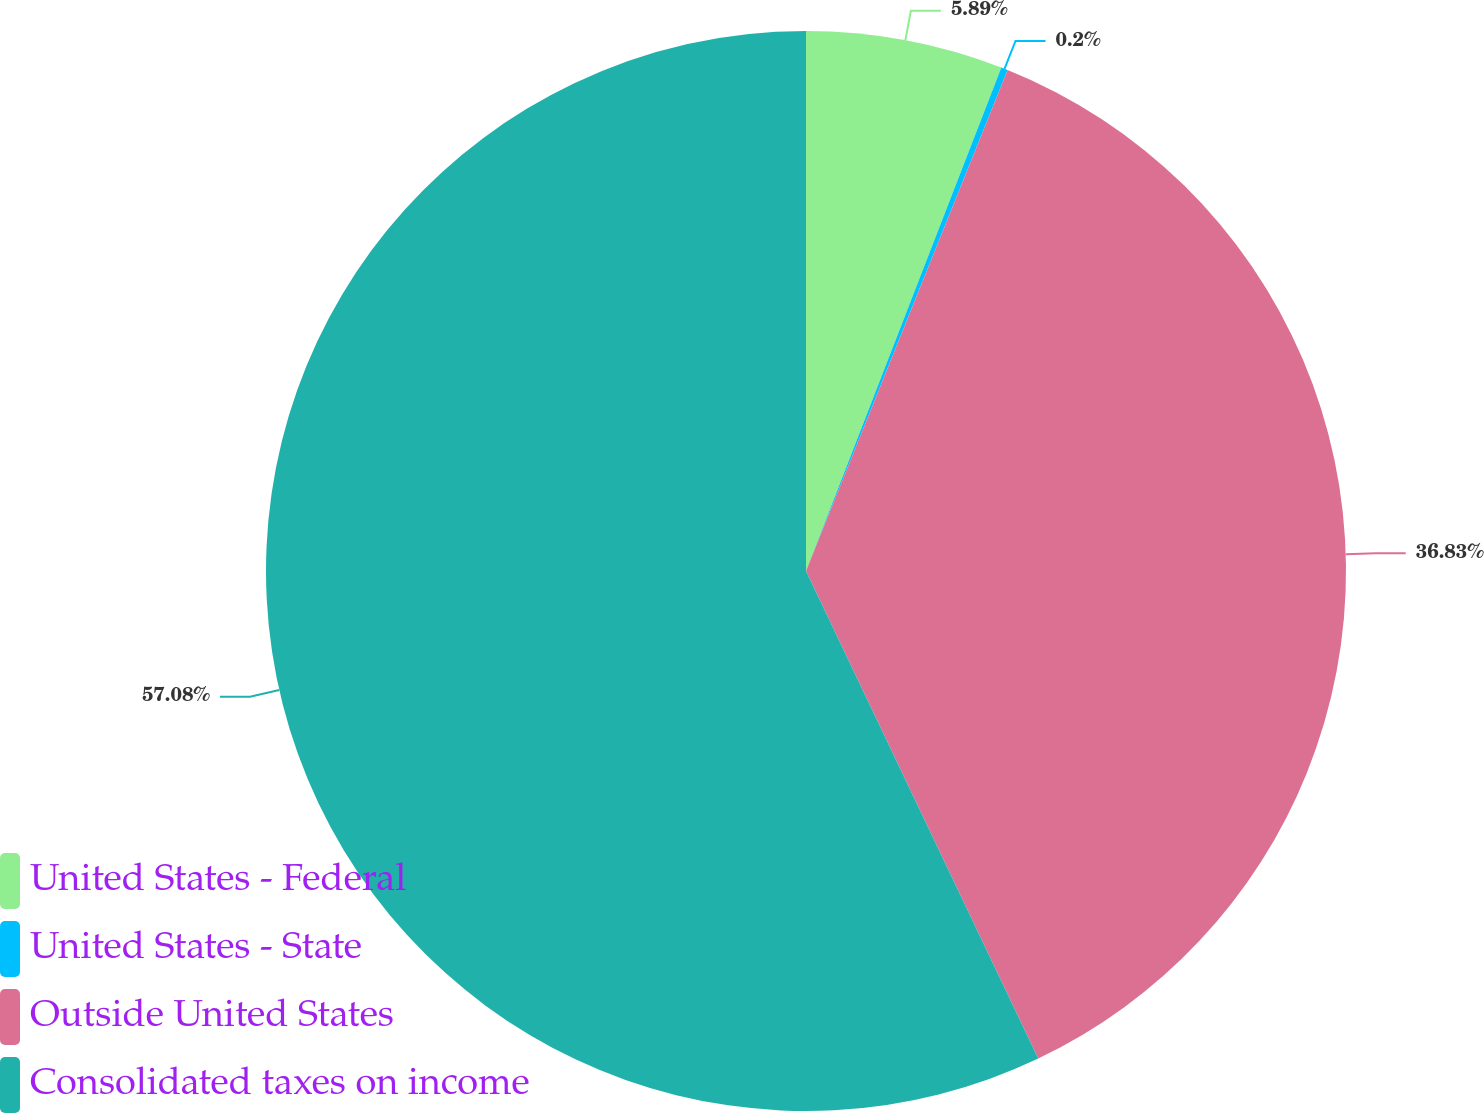<chart> <loc_0><loc_0><loc_500><loc_500><pie_chart><fcel>United States - Federal<fcel>United States - State<fcel>Outside United States<fcel>Consolidated taxes on income<nl><fcel>5.89%<fcel>0.2%<fcel>36.83%<fcel>57.07%<nl></chart> 